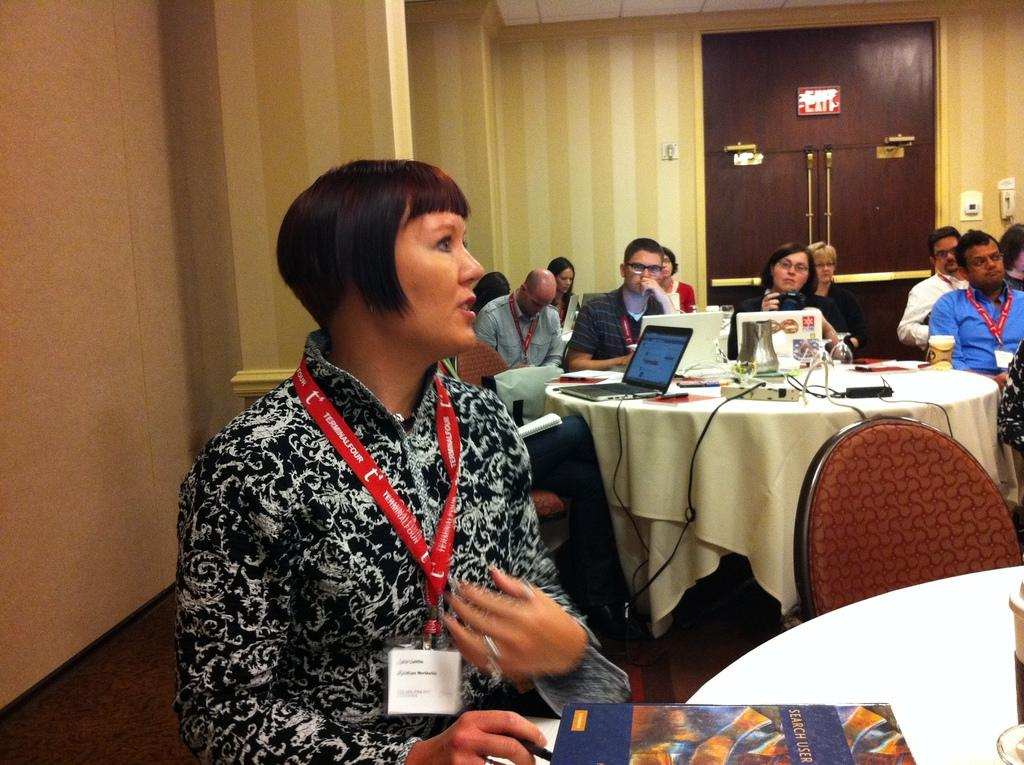What are the people in the image doing? The people in the image are sitting on chairs in front of a table. What objects can be seen on the table? The table contains a laptop, a wire board, books, and a charger. What color is the background of the image? The background of the image is yellow. What type of record can be seen playing on the laptop in the image? There is no record playing on the laptop in the image; it is a laptop, not a record player. 